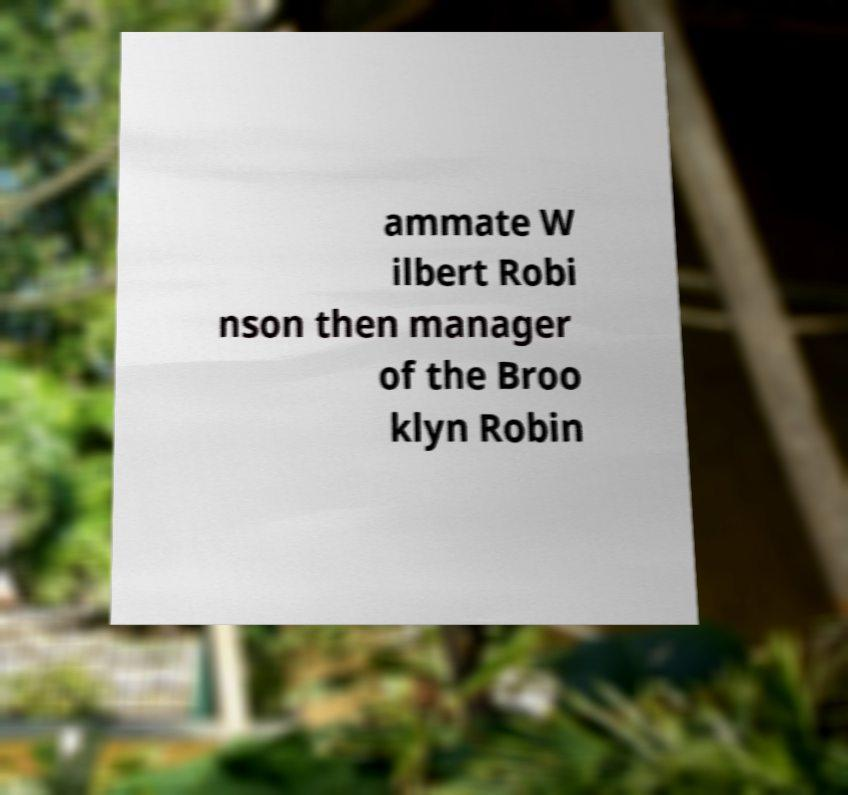Could you assist in decoding the text presented in this image and type it out clearly? ammate W ilbert Robi nson then manager of the Broo klyn Robin 